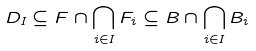Convert formula to latex. <formula><loc_0><loc_0><loc_500><loc_500>D _ { I } \subseteq F \cap \bigcap _ { i \in I } F _ { i } \subseteq B \cap \bigcap _ { i \in I } B _ { i }</formula> 